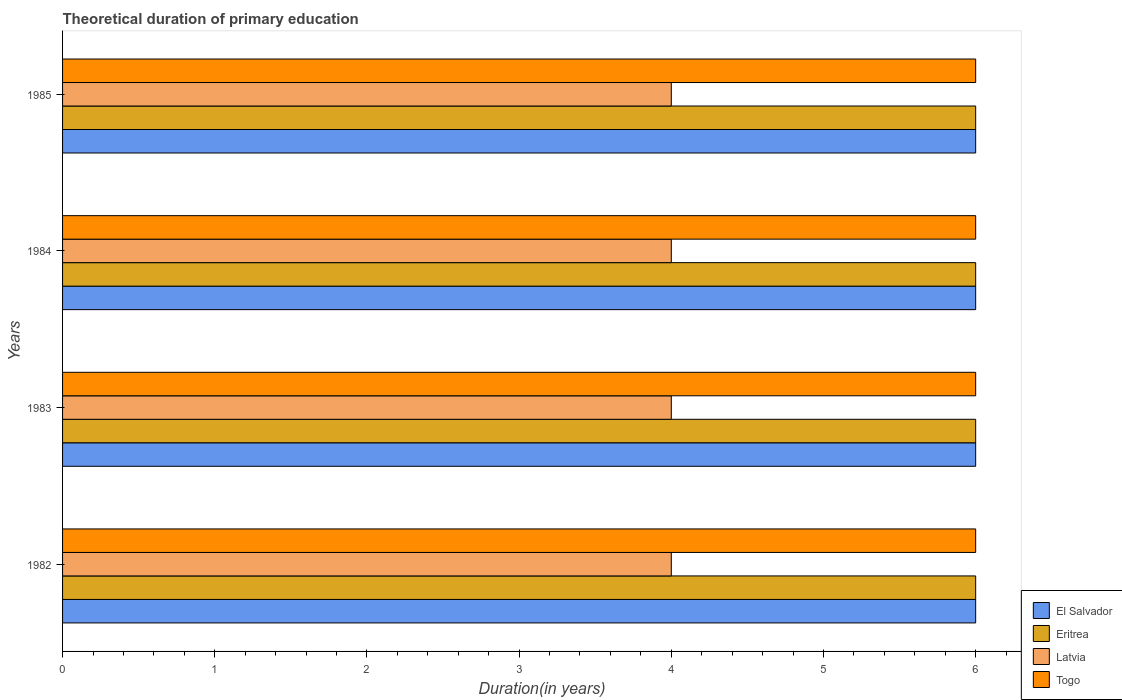How many different coloured bars are there?
Give a very brief answer. 4. How many groups of bars are there?
Keep it short and to the point. 4. Are the number of bars on each tick of the Y-axis equal?
Keep it short and to the point. Yes. How many bars are there on the 2nd tick from the bottom?
Keep it short and to the point. 4. What is the label of the 2nd group of bars from the top?
Keep it short and to the point. 1984. In how many cases, is the number of bars for a given year not equal to the number of legend labels?
Offer a terse response. 0. What is the total theoretical duration of primary education in Togo in 1984?
Your answer should be very brief. 6. Across all years, what is the maximum total theoretical duration of primary education in Eritrea?
Your answer should be very brief. 6. Across all years, what is the minimum total theoretical duration of primary education in Latvia?
Make the answer very short. 4. In which year was the total theoretical duration of primary education in El Salvador minimum?
Provide a short and direct response. 1982. What is the total total theoretical duration of primary education in Togo in the graph?
Make the answer very short. 24. What is the difference between the total theoretical duration of primary education in Togo in 1983 and that in 1985?
Provide a short and direct response. 0. What is the difference between the total theoretical duration of primary education in Eritrea in 1984 and the total theoretical duration of primary education in Latvia in 1982?
Make the answer very short. 2. In the year 1983, what is the difference between the total theoretical duration of primary education in Eritrea and total theoretical duration of primary education in Latvia?
Offer a very short reply. 2. In how many years, is the total theoretical duration of primary education in Latvia greater than 2.2 years?
Provide a short and direct response. 4. What is the ratio of the total theoretical duration of primary education in Latvia in 1983 to that in 1985?
Your response must be concise. 1. Is the difference between the total theoretical duration of primary education in Eritrea in 1983 and 1984 greater than the difference between the total theoretical duration of primary education in Latvia in 1983 and 1984?
Offer a very short reply. No. What is the difference between the highest and the lowest total theoretical duration of primary education in Eritrea?
Make the answer very short. 0. In how many years, is the total theoretical duration of primary education in El Salvador greater than the average total theoretical duration of primary education in El Salvador taken over all years?
Give a very brief answer. 0. Is the sum of the total theoretical duration of primary education in Eritrea in 1983 and 1984 greater than the maximum total theoretical duration of primary education in Latvia across all years?
Provide a short and direct response. Yes. Is it the case that in every year, the sum of the total theoretical duration of primary education in Togo and total theoretical duration of primary education in Eritrea is greater than the sum of total theoretical duration of primary education in El Salvador and total theoretical duration of primary education in Latvia?
Provide a short and direct response. Yes. What does the 3rd bar from the top in 1985 represents?
Provide a succinct answer. Eritrea. What does the 3rd bar from the bottom in 1983 represents?
Offer a terse response. Latvia. Is it the case that in every year, the sum of the total theoretical duration of primary education in El Salvador and total theoretical duration of primary education in Togo is greater than the total theoretical duration of primary education in Latvia?
Provide a short and direct response. Yes. How many bars are there?
Offer a very short reply. 16. How many years are there in the graph?
Offer a very short reply. 4. Where does the legend appear in the graph?
Ensure brevity in your answer.  Bottom right. How many legend labels are there?
Ensure brevity in your answer.  4. What is the title of the graph?
Your response must be concise. Theoretical duration of primary education. What is the label or title of the X-axis?
Your response must be concise. Duration(in years). What is the Duration(in years) in El Salvador in 1982?
Your answer should be very brief. 6. What is the Duration(in years) in Eritrea in 1982?
Keep it short and to the point. 6. What is the Duration(in years) of Togo in 1983?
Provide a succinct answer. 6. What is the Duration(in years) of Eritrea in 1984?
Provide a short and direct response. 6. What is the Duration(in years) of Eritrea in 1985?
Give a very brief answer. 6. What is the Duration(in years) of Latvia in 1985?
Give a very brief answer. 4. What is the Duration(in years) of Togo in 1985?
Provide a short and direct response. 6. Across all years, what is the maximum Duration(in years) in Eritrea?
Keep it short and to the point. 6. What is the total Duration(in years) in El Salvador in the graph?
Provide a short and direct response. 24. What is the total Duration(in years) of Togo in the graph?
Provide a succinct answer. 24. What is the difference between the Duration(in years) in Eritrea in 1982 and that in 1983?
Your response must be concise. 0. What is the difference between the Duration(in years) in El Salvador in 1982 and that in 1984?
Keep it short and to the point. 0. What is the difference between the Duration(in years) in Latvia in 1982 and that in 1984?
Your answer should be very brief. 0. What is the difference between the Duration(in years) of Eritrea in 1982 and that in 1985?
Give a very brief answer. 0. What is the difference between the Duration(in years) in Latvia in 1982 and that in 1985?
Offer a terse response. 0. What is the difference between the Duration(in years) of El Salvador in 1983 and that in 1984?
Make the answer very short. 0. What is the difference between the Duration(in years) of Eritrea in 1983 and that in 1984?
Your answer should be compact. 0. What is the difference between the Duration(in years) of Latvia in 1983 and that in 1984?
Provide a short and direct response. 0. What is the difference between the Duration(in years) in Eritrea in 1983 and that in 1985?
Provide a short and direct response. 0. What is the difference between the Duration(in years) in Latvia in 1983 and that in 1985?
Your answer should be very brief. 0. What is the difference between the Duration(in years) of El Salvador in 1982 and the Duration(in years) of Eritrea in 1983?
Make the answer very short. 0. What is the difference between the Duration(in years) in Eritrea in 1982 and the Duration(in years) in Latvia in 1983?
Provide a succinct answer. 2. What is the difference between the Duration(in years) in Eritrea in 1982 and the Duration(in years) in Togo in 1983?
Your response must be concise. 0. What is the difference between the Duration(in years) of Latvia in 1982 and the Duration(in years) of Togo in 1983?
Offer a very short reply. -2. What is the difference between the Duration(in years) in Eritrea in 1982 and the Duration(in years) in Latvia in 1984?
Keep it short and to the point. 2. What is the difference between the Duration(in years) of El Salvador in 1982 and the Duration(in years) of Latvia in 1985?
Your answer should be very brief. 2. What is the difference between the Duration(in years) in Eritrea in 1982 and the Duration(in years) in Latvia in 1985?
Keep it short and to the point. 2. What is the difference between the Duration(in years) of Eritrea in 1982 and the Duration(in years) of Togo in 1985?
Offer a very short reply. 0. What is the difference between the Duration(in years) of Latvia in 1982 and the Duration(in years) of Togo in 1985?
Make the answer very short. -2. What is the difference between the Duration(in years) of El Salvador in 1983 and the Duration(in years) of Latvia in 1984?
Your answer should be compact. 2. What is the difference between the Duration(in years) in Eritrea in 1983 and the Duration(in years) in Togo in 1984?
Your response must be concise. 0. What is the difference between the Duration(in years) of Latvia in 1983 and the Duration(in years) of Togo in 1984?
Keep it short and to the point. -2. What is the difference between the Duration(in years) in El Salvador in 1983 and the Duration(in years) in Togo in 1985?
Ensure brevity in your answer.  0. What is the difference between the Duration(in years) in Eritrea in 1983 and the Duration(in years) in Latvia in 1985?
Your answer should be very brief. 2. What is the difference between the Duration(in years) in El Salvador in 1984 and the Duration(in years) in Togo in 1985?
Make the answer very short. 0. What is the difference between the Duration(in years) in Latvia in 1984 and the Duration(in years) in Togo in 1985?
Offer a terse response. -2. What is the average Duration(in years) in El Salvador per year?
Your response must be concise. 6. What is the average Duration(in years) in Latvia per year?
Offer a very short reply. 4. In the year 1982, what is the difference between the Duration(in years) in El Salvador and Duration(in years) in Togo?
Make the answer very short. 0. In the year 1982, what is the difference between the Duration(in years) in Eritrea and Duration(in years) in Togo?
Your response must be concise. 0. In the year 1983, what is the difference between the Duration(in years) in Eritrea and Duration(in years) in Togo?
Keep it short and to the point. 0. In the year 1983, what is the difference between the Duration(in years) in Latvia and Duration(in years) in Togo?
Offer a very short reply. -2. In the year 1984, what is the difference between the Duration(in years) in El Salvador and Duration(in years) in Latvia?
Make the answer very short. 2. In the year 1984, what is the difference between the Duration(in years) in El Salvador and Duration(in years) in Togo?
Provide a succinct answer. 0. In the year 1984, what is the difference between the Duration(in years) in Eritrea and Duration(in years) in Latvia?
Make the answer very short. 2. In the year 1984, what is the difference between the Duration(in years) in Eritrea and Duration(in years) in Togo?
Provide a succinct answer. 0. In the year 1985, what is the difference between the Duration(in years) of Eritrea and Duration(in years) of Togo?
Keep it short and to the point. 0. What is the ratio of the Duration(in years) of Latvia in 1982 to that in 1983?
Your response must be concise. 1. What is the ratio of the Duration(in years) in El Salvador in 1982 to that in 1984?
Give a very brief answer. 1. What is the ratio of the Duration(in years) in Togo in 1982 to that in 1984?
Your response must be concise. 1. What is the ratio of the Duration(in years) of El Salvador in 1982 to that in 1985?
Your answer should be compact. 1. What is the ratio of the Duration(in years) in Eritrea in 1982 to that in 1985?
Give a very brief answer. 1. What is the ratio of the Duration(in years) in Latvia in 1982 to that in 1985?
Make the answer very short. 1. What is the ratio of the Duration(in years) of Eritrea in 1983 to that in 1984?
Give a very brief answer. 1. What is the ratio of the Duration(in years) in Togo in 1983 to that in 1984?
Make the answer very short. 1. What is the ratio of the Duration(in years) in El Salvador in 1983 to that in 1985?
Offer a very short reply. 1. What is the ratio of the Duration(in years) in Eritrea in 1983 to that in 1985?
Provide a succinct answer. 1. What is the ratio of the Duration(in years) of Togo in 1983 to that in 1985?
Your answer should be compact. 1. What is the ratio of the Duration(in years) of Togo in 1984 to that in 1985?
Make the answer very short. 1. What is the difference between the highest and the second highest Duration(in years) of El Salvador?
Make the answer very short. 0. What is the difference between the highest and the second highest Duration(in years) in Eritrea?
Make the answer very short. 0. What is the difference between the highest and the second highest Duration(in years) in Latvia?
Give a very brief answer. 0. What is the difference between the highest and the second highest Duration(in years) of Togo?
Offer a terse response. 0. What is the difference between the highest and the lowest Duration(in years) of Eritrea?
Your response must be concise. 0. What is the difference between the highest and the lowest Duration(in years) of Togo?
Offer a very short reply. 0. 